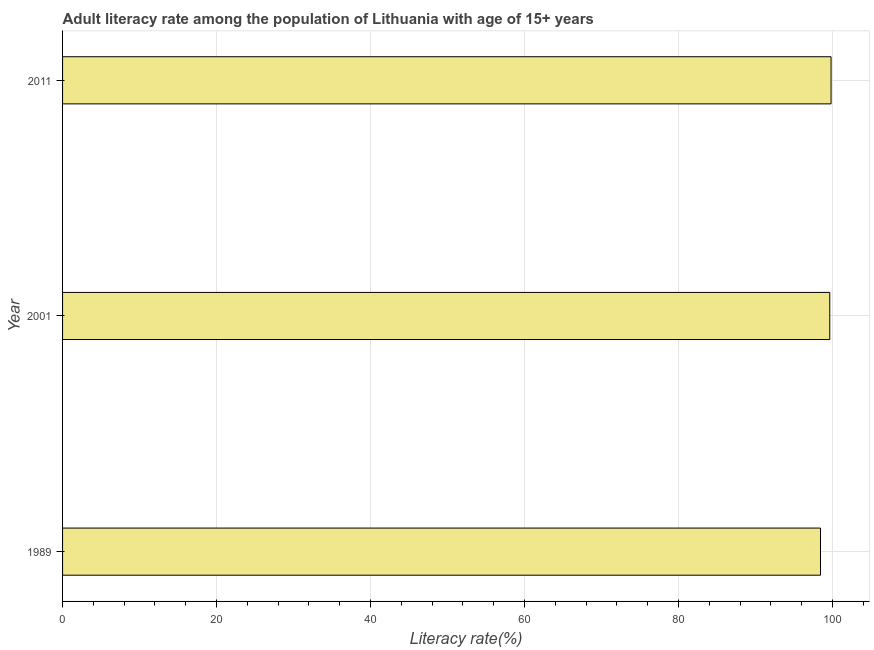Does the graph contain grids?
Provide a succinct answer. Yes. What is the title of the graph?
Provide a short and direct response. Adult literacy rate among the population of Lithuania with age of 15+ years. What is the label or title of the X-axis?
Your answer should be very brief. Literacy rate(%). What is the label or title of the Y-axis?
Give a very brief answer. Year. What is the adult literacy rate in 2001?
Your answer should be compact. 99.65. Across all years, what is the maximum adult literacy rate?
Provide a succinct answer. 99.82. Across all years, what is the minimum adult literacy rate?
Offer a terse response. 98.44. In which year was the adult literacy rate maximum?
Offer a terse response. 2011. In which year was the adult literacy rate minimum?
Keep it short and to the point. 1989. What is the sum of the adult literacy rate?
Your response must be concise. 297.9. What is the difference between the adult literacy rate in 1989 and 2011?
Provide a short and direct response. -1.37. What is the average adult literacy rate per year?
Your response must be concise. 99.3. What is the median adult literacy rate?
Your response must be concise. 99.65. In how many years, is the adult literacy rate greater than 64 %?
Give a very brief answer. 3. Do a majority of the years between 2001 and 2011 (inclusive) have adult literacy rate greater than 40 %?
Make the answer very short. Yes. Is the adult literacy rate in 1989 less than that in 2011?
Your answer should be very brief. Yes. Is the difference between the adult literacy rate in 1989 and 2011 greater than the difference between any two years?
Provide a succinct answer. Yes. What is the difference between the highest and the second highest adult literacy rate?
Ensure brevity in your answer.  0.17. Is the sum of the adult literacy rate in 2001 and 2011 greater than the maximum adult literacy rate across all years?
Give a very brief answer. Yes. What is the difference between the highest and the lowest adult literacy rate?
Your answer should be very brief. 1.37. In how many years, is the adult literacy rate greater than the average adult literacy rate taken over all years?
Give a very brief answer. 2. Are all the bars in the graph horizontal?
Provide a succinct answer. Yes. What is the difference between two consecutive major ticks on the X-axis?
Make the answer very short. 20. What is the Literacy rate(%) of 1989?
Provide a short and direct response. 98.44. What is the Literacy rate(%) in 2001?
Provide a short and direct response. 99.65. What is the Literacy rate(%) of 2011?
Provide a succinct answer. 99.82. What is the difference between the Literacy rate(%) in 1989 and 2001?
Provide a short and direct response. -1.2. What is the difference between the Literacy rate(%) in 1989 and 2011?
Ensure brevity in your answer.  -1.37. What is the difference between the Literacy rate(%) in 2001 and 2011?
Make the answer very short. -0.17. What is the ratio of the Literacy rate(%) in 2001 to that in 2011?
Give a very brief answer. 1. 